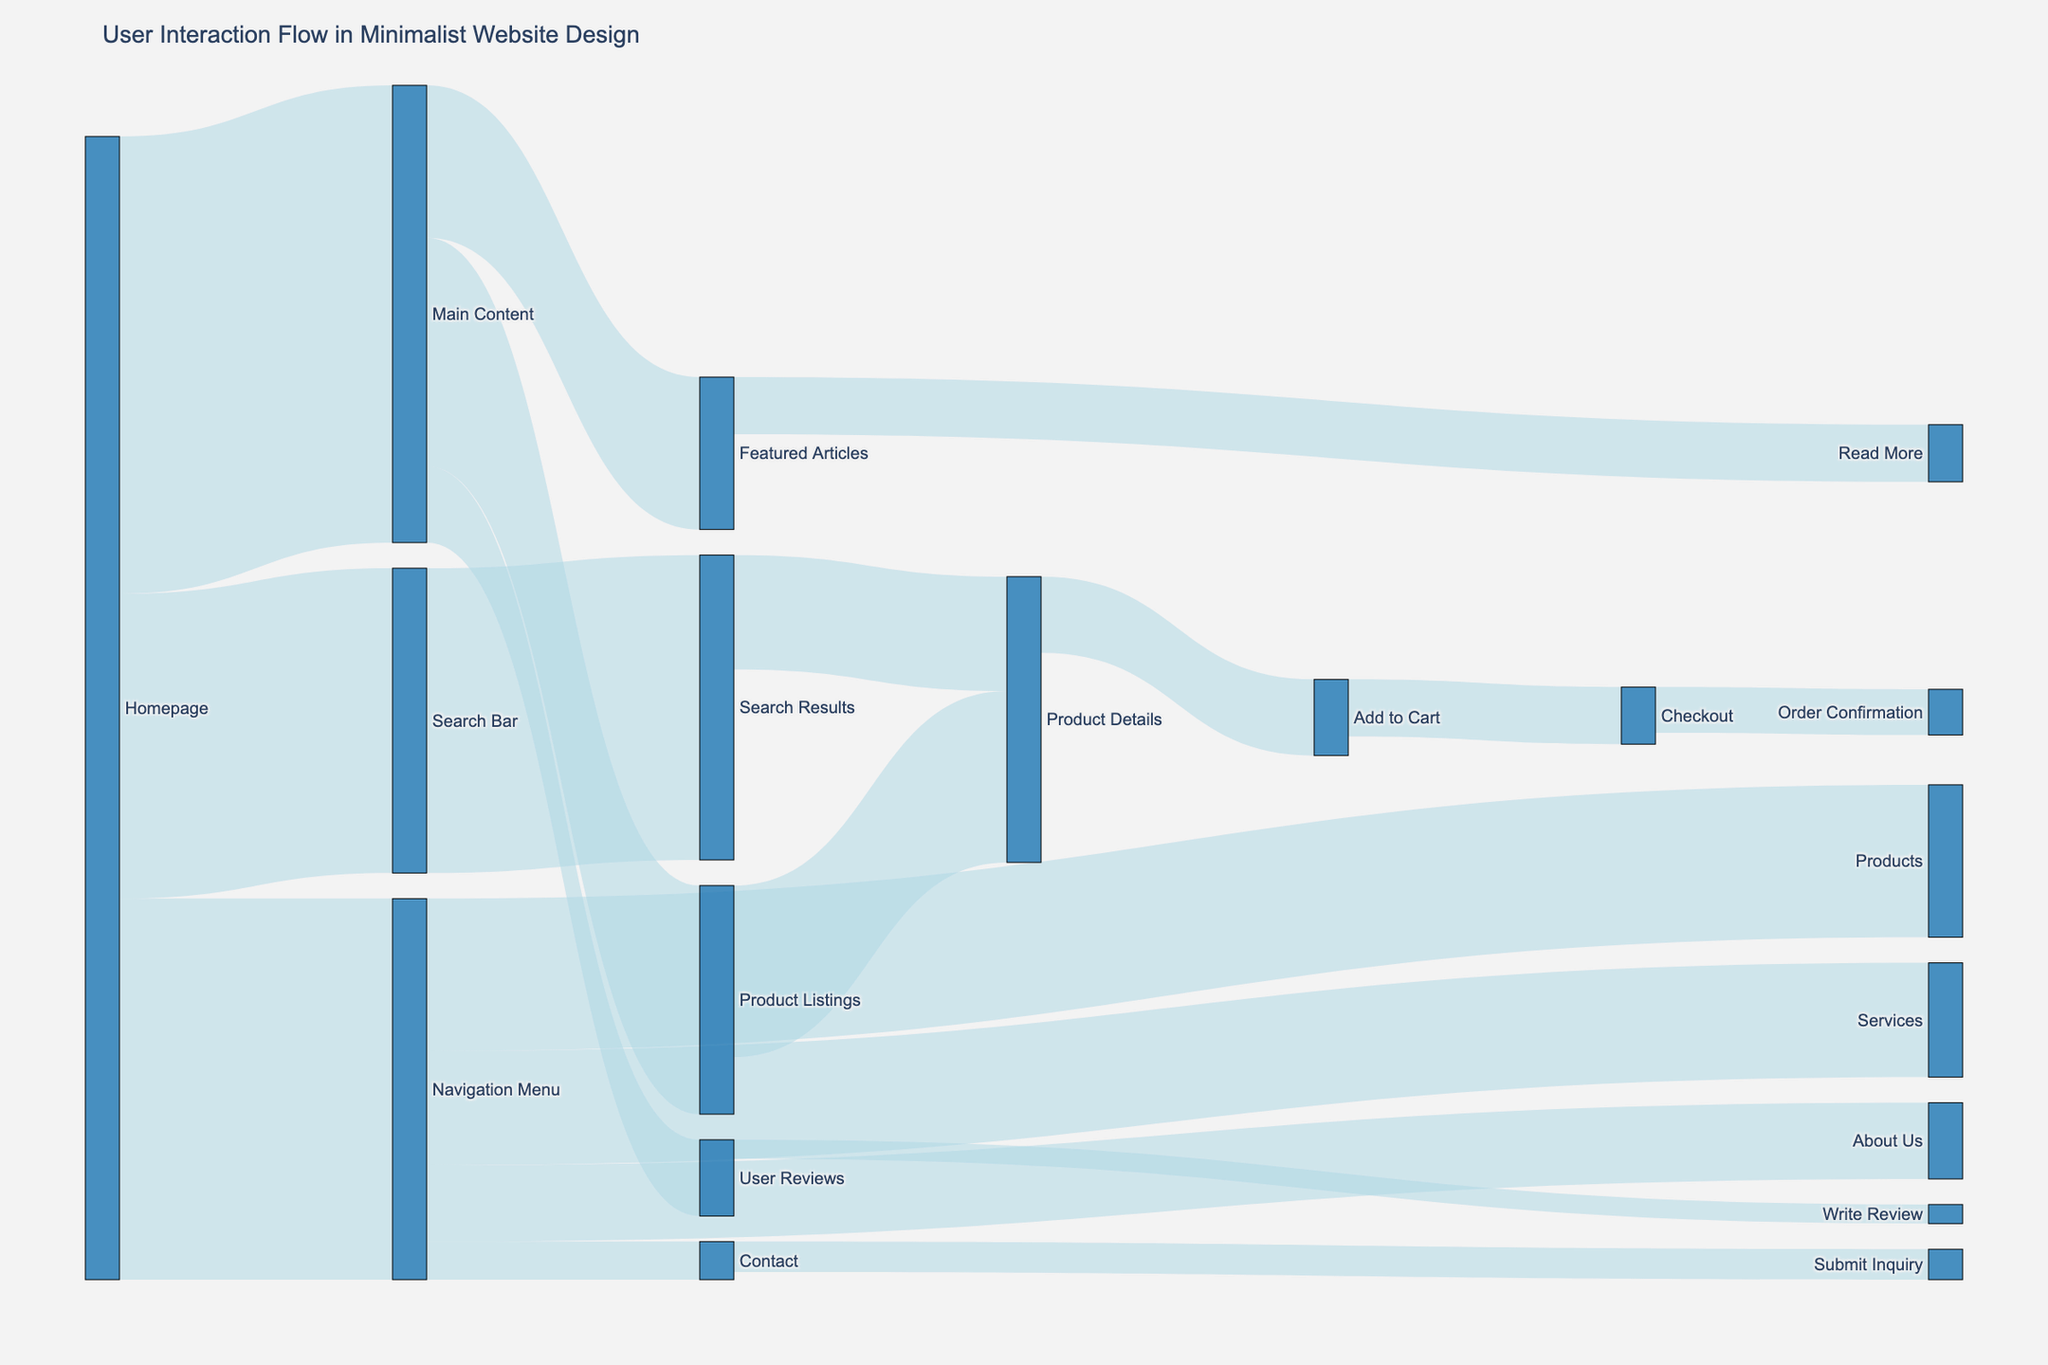How many users navigated from the Homepage to the Main Content? The Sankey diagram shows different flows from the Homepage. The flow labeled 'Homepage to Main Content' has a value associated with it.
Answer: 1200 Which navigation route had the least user engagement from the Navigation Menu? From the Sankey diagram, examine the links emanating from the Navigation Menu. The route with the smallest value will be the one with the least engagement.
Answer: Contact with 100 users How many users engaged with the Search Bar and then viewed Product Details through Search Results? First, find the value from the Homepage to the Search Bar. Then follow the flow from the Search Bar to the Search Results and finally to the Product Details. Sum the values along this path. 800 (Homepage to Search Bar) and 300 (Search Results to Product Details).
Answer: 300 What is the total number of users who visited the Product Listings page? Identify all paths leading to the Product Listings page and sum the values. There is one direct link from Main Content to Product Listings, with a value of 600.
Answer: 600 Which functional element has the highest initial user interaction from the Homepage? Look at the flows originating from the Homepage. Compare the values associated with each target. The highest value indicates the most engaged functional element. Main Content has the highest value of 1200 users.
Answer: Main Content What percentage of users who reached the 'Add to Cart' page proceeded to checkout? First, find the number of users who reached the 'Add to Cart' page, which is 200. Then find the number of users who proceeded to Checkout, which is 150. Calculate the percentage: (150/200) * 100 = 75%.
Answer: 75% How many users interacted with the Navigation Menu but did not navigate to 'Products'? Identify the total users who interacted with the Navigation Menu, which is 1000. Subtract the users who navigated to 'Products', which is 400. 1000 - 400 = 600.
Answer: 600 What is the total number of users who completed an order? Check the Sankey diagram for the value associated with the path from Checkout to Order Confirmation.
Answer: 120 Which path had more traffic: 'Main Content to Featured Articles' or 'Main Content to User Reviews'? Identify the values of both paths in the Sankey diagram. Compare the values. 'Main Content to Featured Articles' has 400 users, while 'Main Content to User Reviews' has 200 users.
Answer: Main Content to Featured Articles 